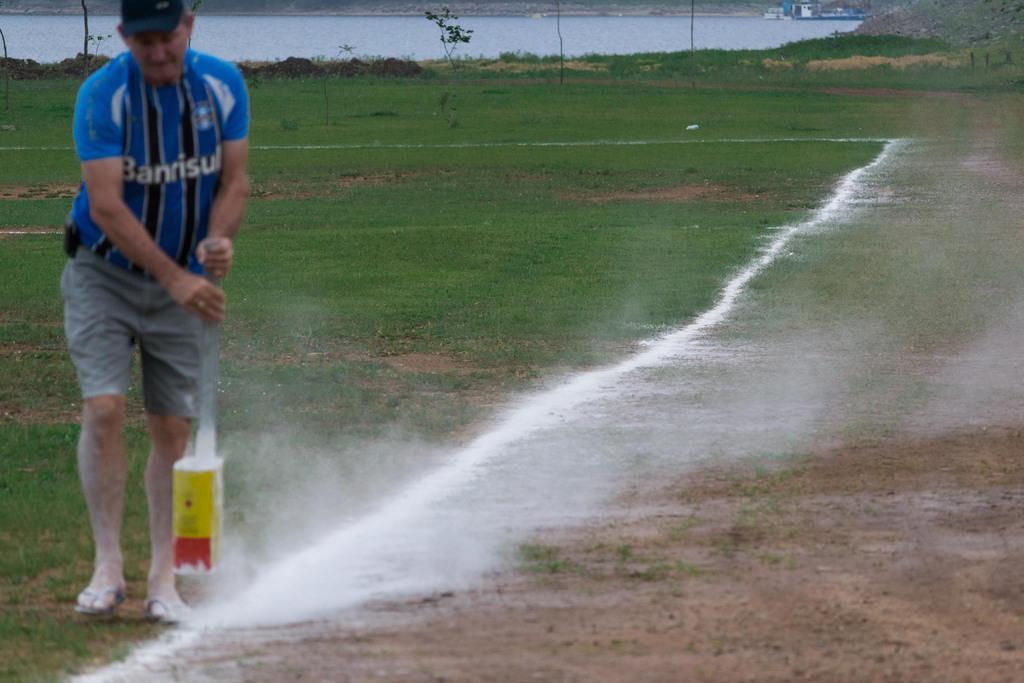What does his shirt say?
Ensure brevity in your answer.  Banrisul. 